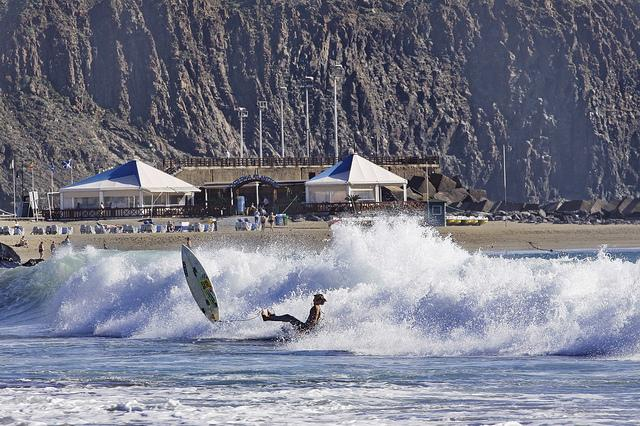Why is he not on the surfboard?

Choices:
A) fell off
B) jumped off
C) fell asleep
D) too cold fell off 